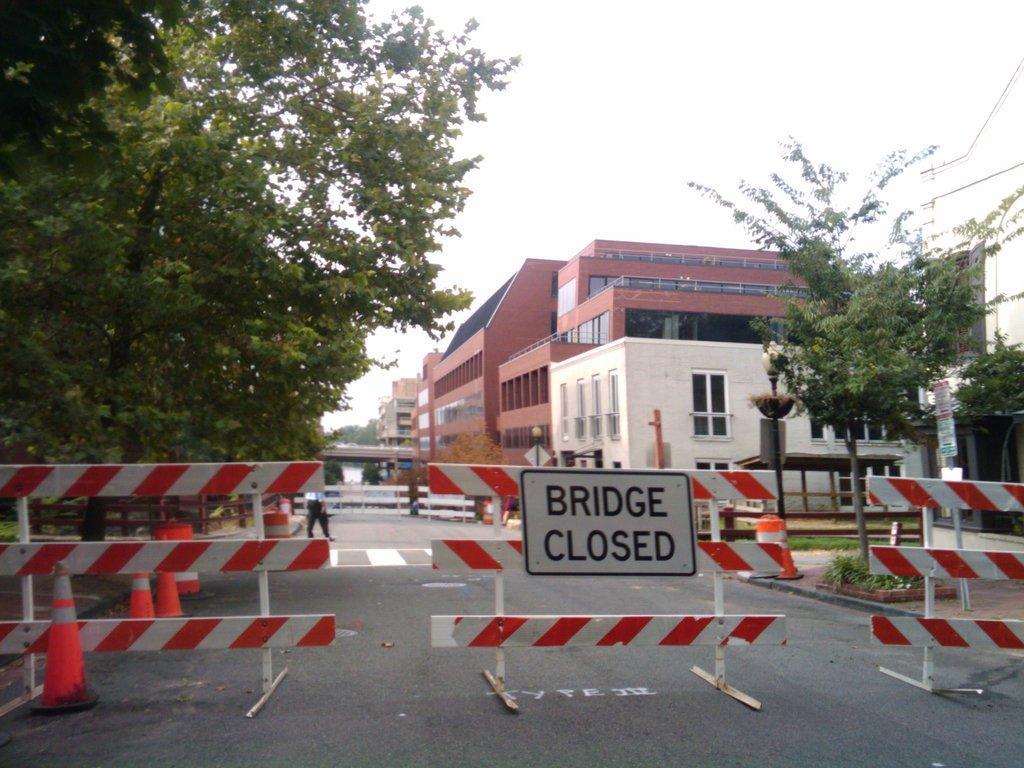Can you describe this image briefly? In this image there is the sky truncated towards the top of the image, there are buildings, there is a building truncated towards the right of the image, there is tree truncated towards the left of the image, there is tree truncated towards the right of the image, there are poles, there is a board, there is text on the board, there is road truncated towards the bottom of the image, there is a person walking on the road, there are objects on the road, there are objects truncated towards the right of the image, there are objects truncated towards the left of the image. 